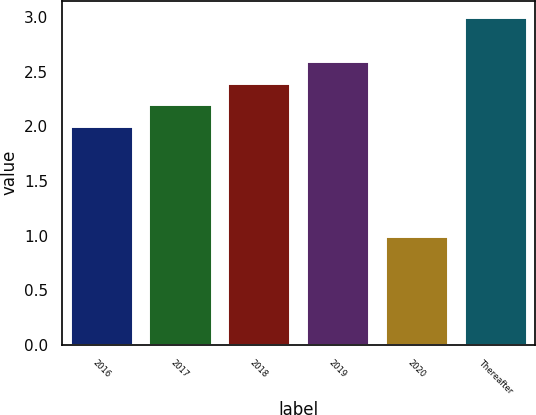<chart> <loc_0><loc_0><loc_500><loc_500><bar_chart><fcel>2016<fcel>2017<fcel>2018<fcel>2019<fcel>2020<fcel>Thereafter<nl><fcel>2<fcel>2.2<fcel>2.4<fcel>2.6<fcel>1<fcel>3<nl></chart> 